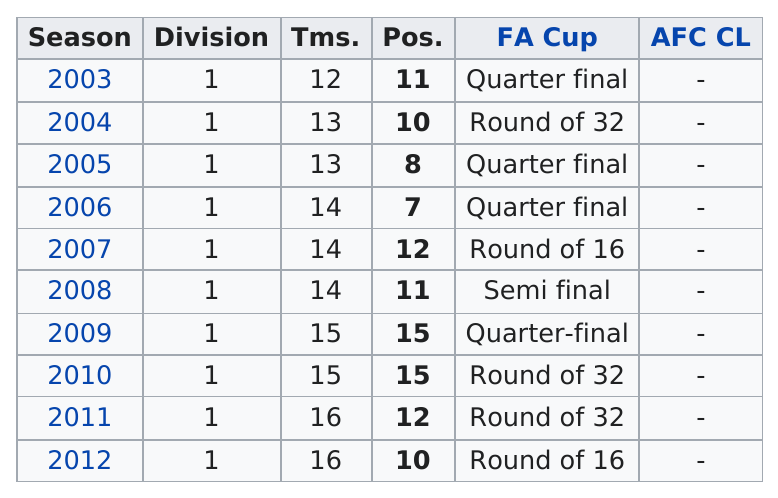Draw attention to some important aspects in this diagram. In 2007, 14 teams competed. The football team made it the farthest in the FA Cup in the year 2008. Daegu FC finished in the top 10 of the K League Classic in the year 2004. The total number of times between 2003 and 2012 that they made it to the quarter finals was 4. After the FA Cup tournament in 2009, the team managed to advance to the Round of 16. 